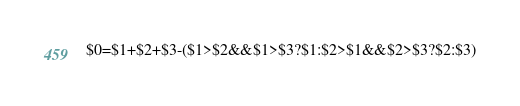Convert code to text. <code><loc_0><loc_0><loc_500><loc_500><_Awk_>$0=$1+$2+$3-($1>$2&&$1>$3?$1:$2>$1&&$2>$3?$2:$3)</code> 